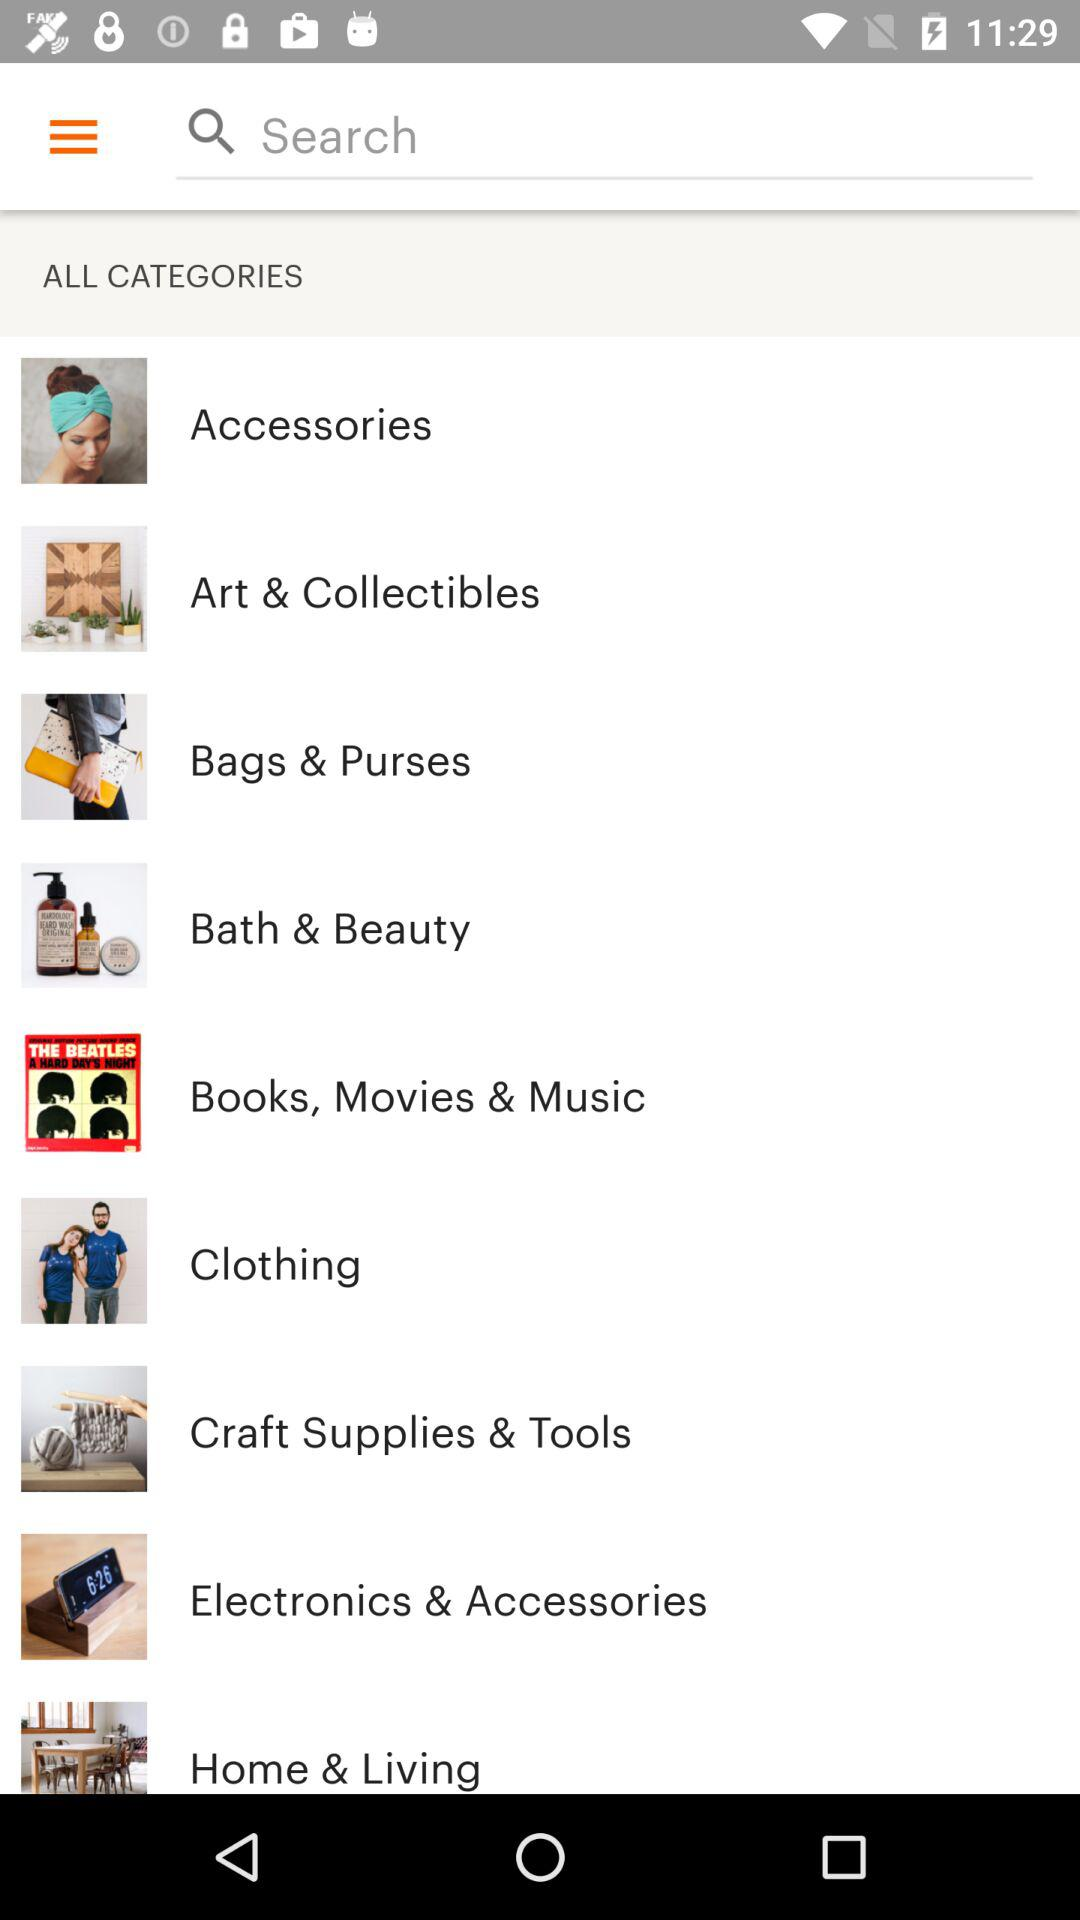What are the available categories? The available categories are "Accessories", "Art & Collectibles", "Bags & Purses", "Bath & Beauty", "Books, Movies & Music", "Clothing", "Craft Supplies & Tools", "Electronics & Accessories" and "Home & Living". 